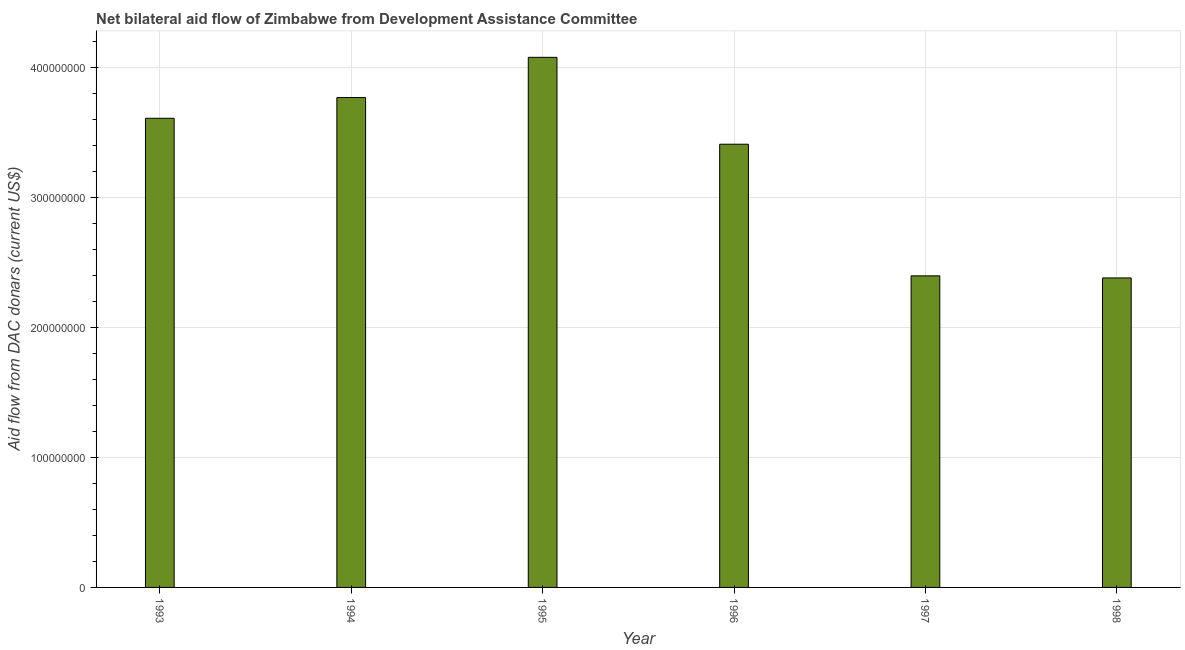What is the title of the graph?
Give a very brief answer. Net bilateral aid flow of Zimbabwe from Development Assistance Committee. What is the label or title of the Y-axis?
Offer a terse response. Aid flow from DAC donars (current US$). What is the net bilateral aid flows from dac donors in 1995?
Provide a succinct answer. 4.08e+08. Across all years, what is the maximum net bilateral aid flows from dac donors?
Make the answer very short. 4.08e+08. Across all years, what is the minimum net bilateral aid flows from dac donors?
Provide a short and direct response. 2.38e+08. In which year was the net bilateral aid flows from dac donors maximum?
Offer a terse response. 1995. What is the sum of the net bilateral aid flows from dac donors?
Make the answer very short. 1.97e+09. What is the difference between the net bilateral aid flows from dac donors in 1996 and 1997?
Offer a very short reply. 1.01e+08. What is the average net bilateral aid flows from dac donors per year?
Provide a succinct answer. 3.28e+08. What is the median net bilateral aid flows from dac donors?
Your answer should be compact. 3.51e+08. In how many years, is the net bilateral aid flows from dac donors greater than 400000000 US$?
Your answer should be very brief. 1. What is the ratio of the net bilateral aid flows from dac donors in 1995 to that in 1996?
Provide a short and direct response. 1.2. Is the net bilateral aid flows from dac donors in 1994 less than that in 1997?
Provide a succinct answer. No. Is the difference between the net bilateral aid flows from dac donors in 1993 and 1998 greater than the difference between any two years?
Provide a short and direct response. No. What is the difference between the highest and the second highest net bilateral aid flows from dac donors?
Provide a succinct answer. 3.10e+07. What is the difference between the highest and the lowest net bilateral aid flows from dac donors?
Make the answer very short. 1.70e+08. How many bars are there?
Offer a very short reply. 6. What is the difference between two consecutive major ticks on the Y-axis?
Provide a short and direct response. 1.00e+08. What is the Aid flow from DAC donars (current US$) in 1993?
Make the answer very short. 3.61e+08. What is the Aid flow from DAC donars (current US$) in 1994?
Your answer should be very brief. 3.77e+08. What is the Aid flow from DAC donars (current US$) in 1995?
Give a very brief answer. 4.08e+08. What is the Aid flow from DAC donars (current US$) of 1996?
Your answer should be very brief. 3.41e+08. What is the Aid flow from DAC donars (current US$) in 1997?
Ensure brevity in your answer.  2.40e+08. What is the Aid flow from DAC donars (current US$) in 1998?
Ensure brevity in your answer.  2.38e+08. What is the difference between the Aid flow from DAC donars (current US$) in 1993 and 1994?
Your response must be concise. -1.60e+07. What is the difference between the Aid flow from DAC donars (current US$) in 1993 and 1995?
Your answer should be compact. -4.69e+07. What is the difference between the Aid flow from DAC donars (current US$) in 1993 and 1996?
Keep it short and to the point. 2.00e+07. What is the difference between the Aid flow from DAC donars (current US$) in 1993 and 1997?
Your answer should be very brief. 1.21e+08. What is the difference between the Aid flow from DAC donars (current US$) in 1993 and 1998?
Keep it short and to the point. 1.23e+08. What is the difference between the Aid flow from DAC donars (current US$) in 1994 and 1995?
Offer a very short reply. -3.10e+07. What is the difference between the Aid flow from DAC donars (current US$) in 1994 and 1996?
Make the answer very short. 3.59e+07. What is the difference between the Aid flow from DAC donars (current US$) in 1994 and 1997?
Provide a succinct answer. 1.37e+08. What is the difference between the Aid flow from DAC donars (current US$) in 1994 and 1998?
Ensure brevity in your answer.  1.39e+08. What is the difference between the Aid flow from DAC donars (current US$) in 1995 and 1996?
Provide a short and direct response. 6.69e+07. What is the difference between the Aid flow from DAC donars (current US$) in 1995 and 1997?
Provide a succinct answer. 1.68e+08. What is the difference between the Aid flow from DAC donars (current US$) in 1995 and 1998?
Provide a succinct answer. 1.70e+08. What is the difference between the Aid flow from DAC donars (current US$) in 1996 and 1997?
Provide a short and direct response. 1.01e+08. What is the difference between the Aid flow from DAC donars (current US$) in 1996 and 1998?
Offer a terse response. 1.03e+08. What is the difference between the Aid flow from DAC donars (current US$) in 1997 and 1998?
Offer a terse response. 1.59e+06. What is the ratio of the Aid flow from DAC donars (current US$) in 1993 to that in 1994?
Offer a terse response. 0.96. What is the ratio of the Aid flow from DAC donars (current US$) in 1993 to that in 1995?
Provide a succinct answer. 0.89. What is the ratio of the Aid flow from DAC donars (current US$) in 1993 to that in 1996?
Ensure brevity in your answer.  1.06. What is the ratio of the Aid flow from DAC donars (current US$) in 1993 to that in 1997?
Make the answer very short. 1.51. What is the ratio of the Aid flow from DAC donars (current US$) in 1993 to that in 1998?
Your response must be concise. 1.52. What is the ratio of the Aid flow from DAC donars (current US$) in 1994 to that in 1995?
Offer a terse response. 0.92. What is the ratio of the Aid flow from DAC donars (current US$) in 1994 to that in 1996?
Make the answer very short. 1.1. What is the ratio of the Aid flow from DAC donars (current US$) in 1994 to that in 1997?
Your answer should be very brief. 1.57. What is the ratio of the Aid flow from DAC donars (current US$) in 1994 to that in 1998?
Provide a succinct answer. 1.58. What is the ratio of the Aid flow from DAC donars (current US$) in 1995 to that in 1996?
Your answer should be very brief. 1.2. What is the ratio of the Aid flow from DAC donars (current US$) in 1995 to that in 1997?
Provide a succinct answer. 1.7. What is the ratio of the Aid flow from DAC donars (current US$) in 1995 to that in 1998?
Your answer should be compact. 1.71. What is the ratio of the Aid flow from DAC donars (current US$) in 1996 to that in 1997?
Your answer should be compact. 1.42. What is the ratio of the Aid flow from DAC donars (current US$) in 1996 to that in 1998?
Provide a succinct answer. 1.43. 